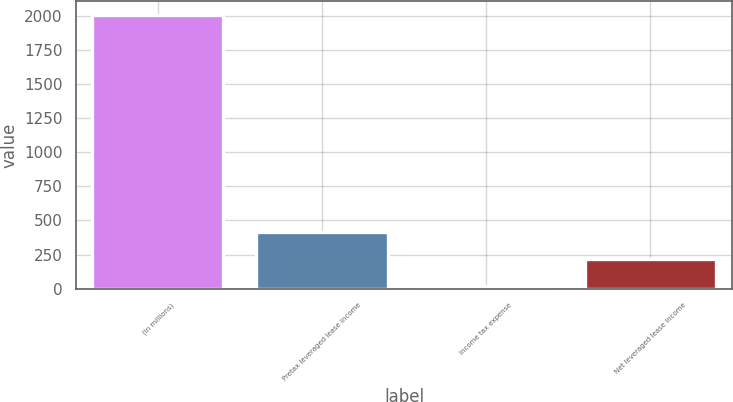Convert chart. <chart><loc_0><loc_0><loc_500><loc_500><bar_chart><fcel>(in millions)<fcel>Pretax leveraged lease income<fcel>Income tax expense<fcel>Net leveraged lease income<nl><fcel>2004<fcel>416<fcel>19<fcel>217.5<nl></chart> 